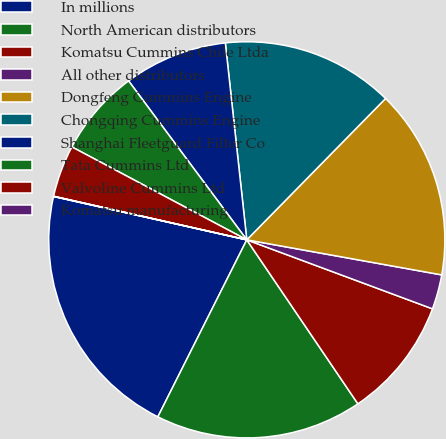Convert chart to OTSL. <chart><loc_0><loc_0><loc_500><loc_500><pie_chart><fcel>In millions<fcel>North American distributors<fcel>Komatsu Cummins Chile Ltda<fcel>All other distributors<fcel>Dongfeng Cummins Engine<fcel>Chongqing Cummins Engine<fcel>Shanghai Fleetguard Filter Co<fcel>Tata Cummins Ltd<fcel>Valvoline Cummins Ltd<fcel>Komatsu manufacturing<nl><fcel>21.1%<fcel>16.89%<fcel>9.86%<fcel>2.83%<fcel>15.48%<fcel>14.08%<fcel>8.45%<fcel>7.05%<fcel>4.24%<fcel>0.02%<nl></chart> 